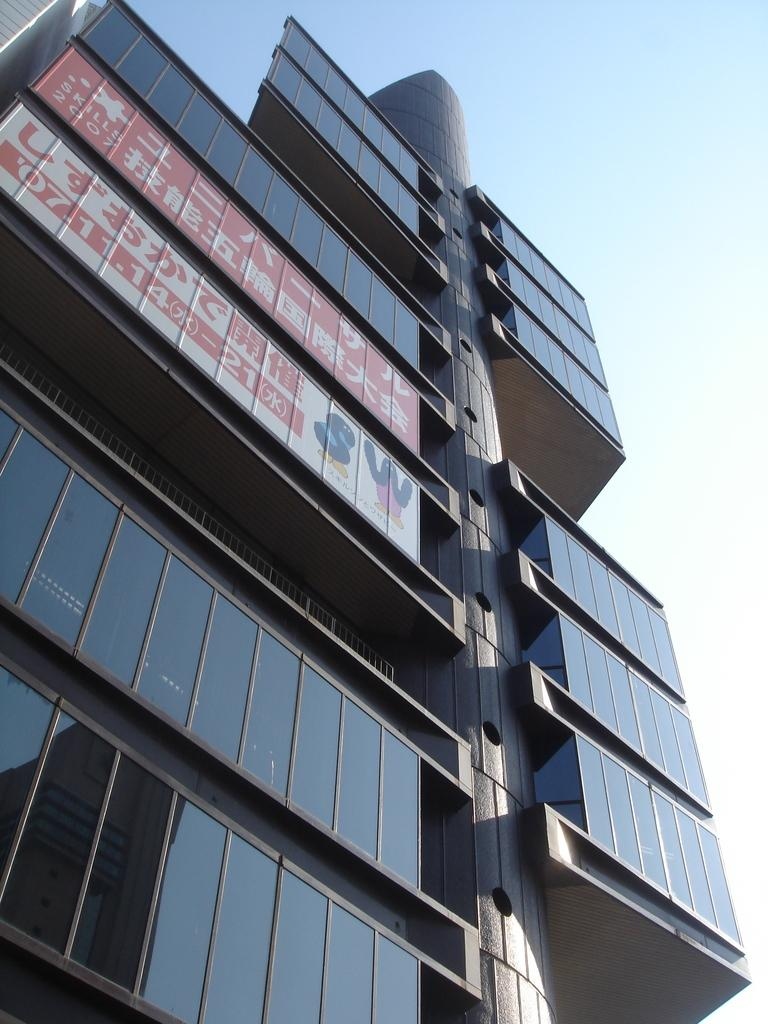What type of building is in the image? There is a glass building in the image. Are there any additional features attached to the building? Yes, boards are attached to the building. What can be seen in the background of the image? The sky is visible in the image. What is the color of the sky in the image? The sky has a white and blue color in the image. How many eyes can be seen on the building in the image? There are no eyes visible on the building in the image. What is the alarm status of the building in the image? There is no information about an alarm in the image, as it only shows a glass building with boards attached. 